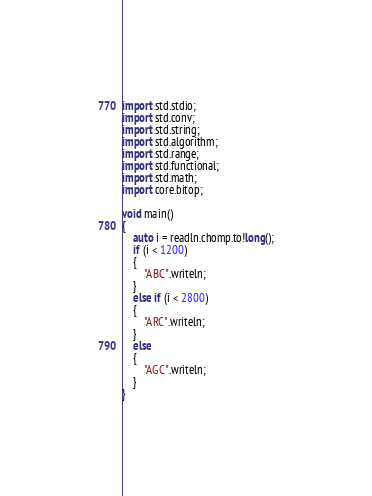Convert code to text. <code><loc_0><loc_0><loc_500><loc_500><_D_>import std.stdio;
import std.conv;
import std.string;
import std.algorithm;
import std.range;
import std.functional;
import std.math;
import core.bitop;

void main()
{
    auto i = readln.chomp.to!long();
    if (i < 1200)
    {
        "ABC".writeln;
    }
    else if (i < 2800)
    {
        "ARC".writeln;
    }
    else
    {
        "AGC".writeln;
    }
}
</code> 